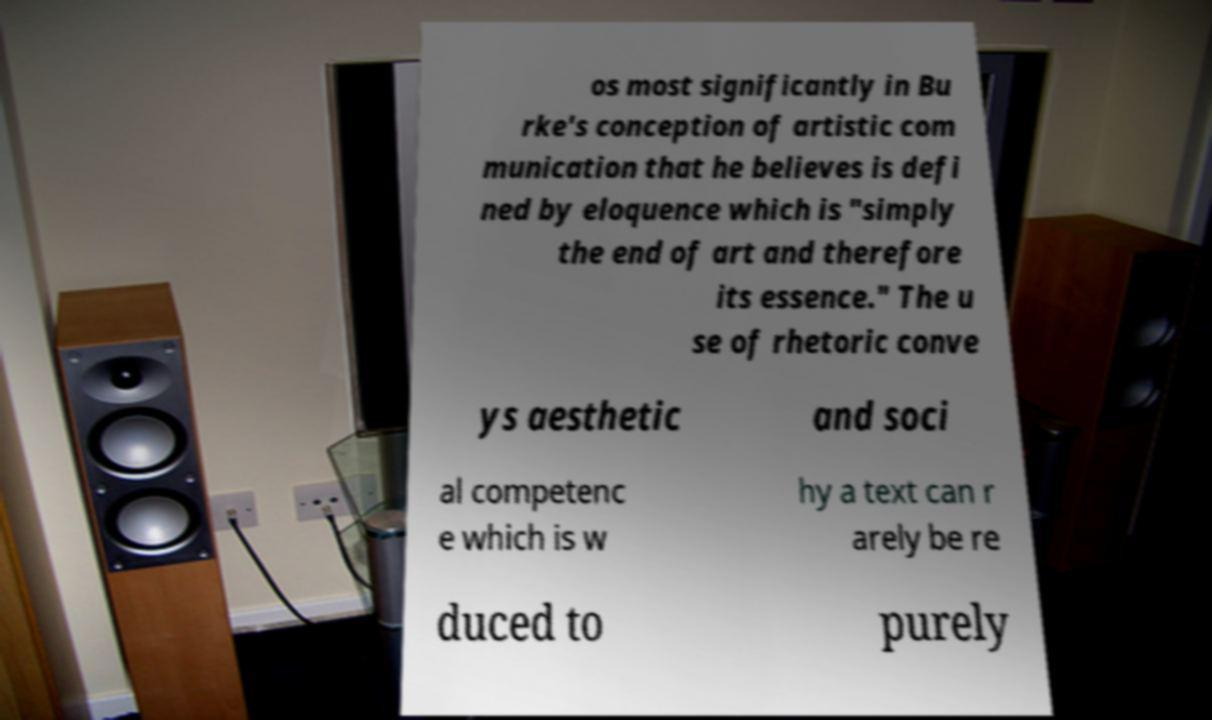Could you extract and type out the text from this image? os most significantly in Bu rke's conception of artistic com munication that he believes is defi ned by eloquence which is "simply the end of art and therefore its essence." The u se of rhetoric conve ys aesthetic and soci al competenc e which is w hy a text can r arely be re duced to purely 